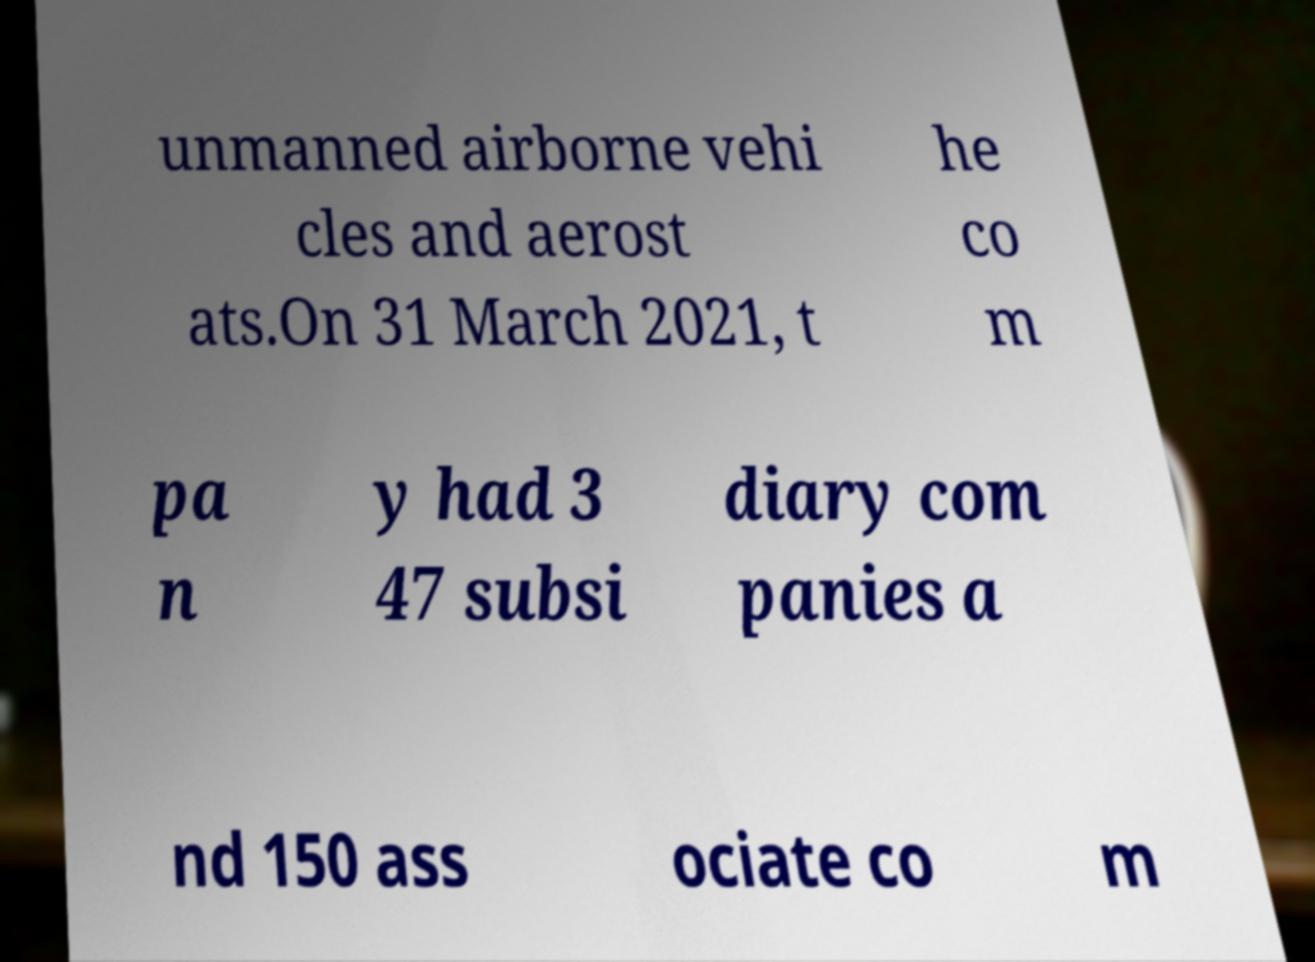There's text embedded in this image that I need extracted. Can you transcribe it verbatim? unmanned airborne vehi cles and aerost ats.On 31 March 2021, t he co m pa n y had 3 47 subsi diary com panies a nd 150 ass ociate co m 